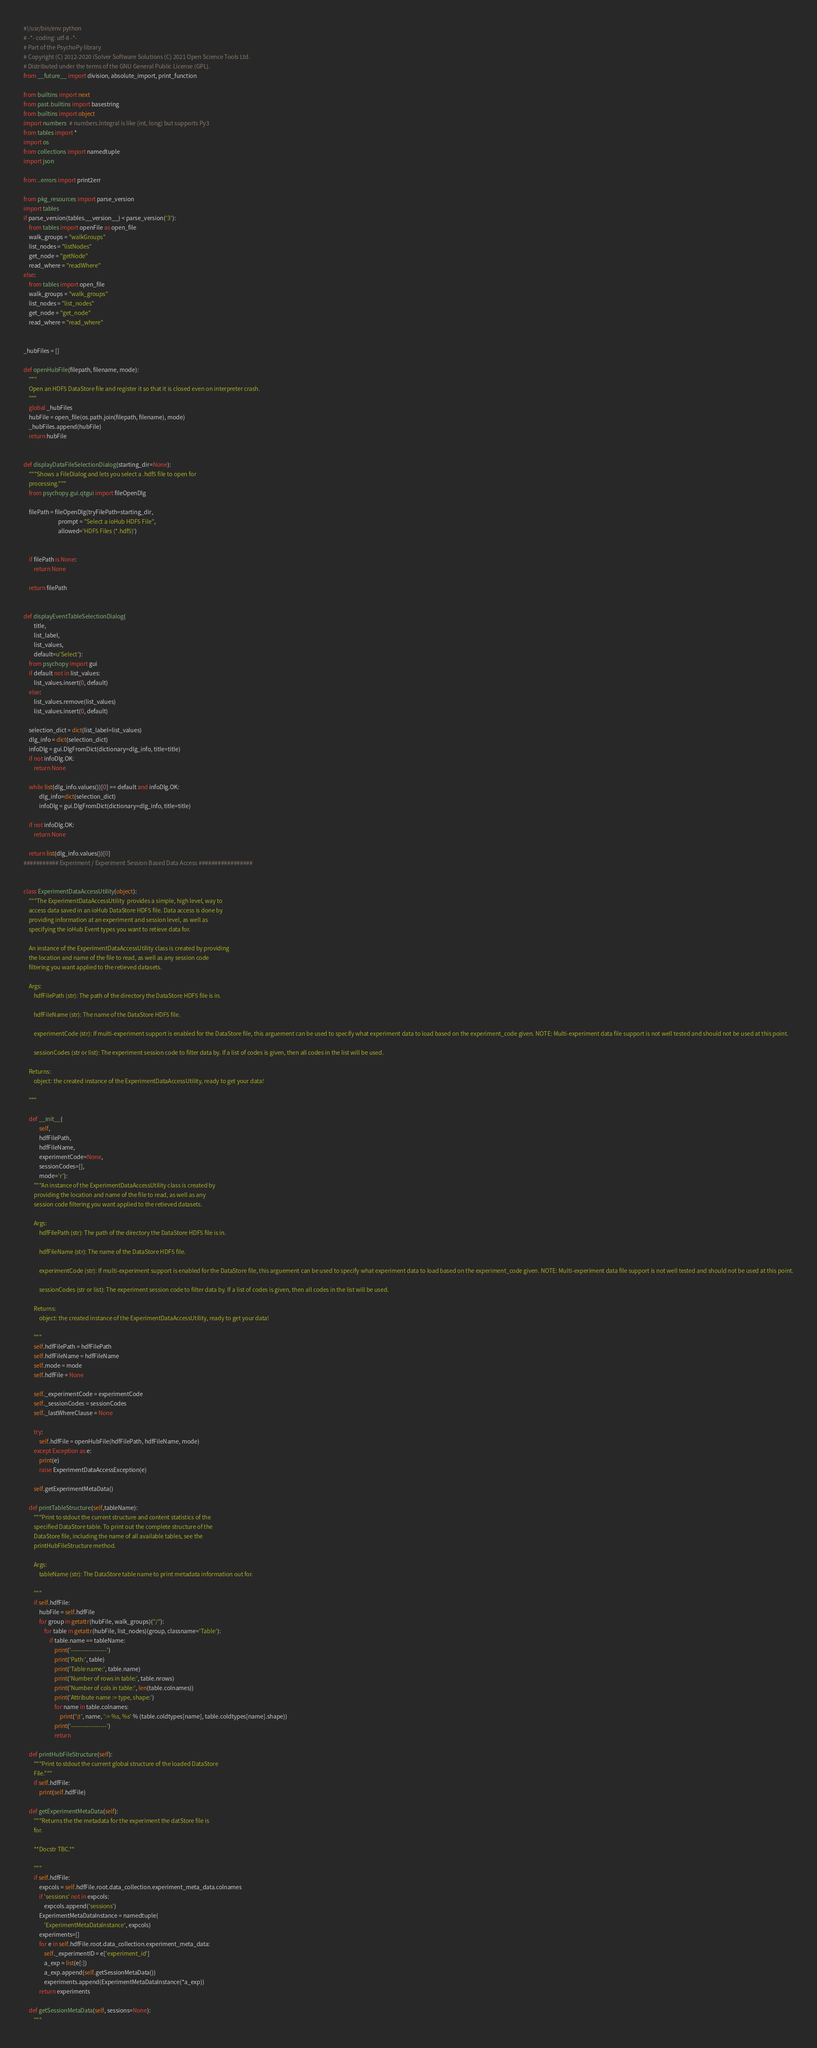Convert code to text. <code><loc_0><loc_0><loc_500><loc_500><_Python_>#!/usr/bin/env python
# -*- coding: utf-8 -*-
# Part of the PsychoPy library
# Copyright (C) 2012-2020 iSolver Software Solutions (C) 2021 Open Science Tools Ltd.
# Distributed under the terms of the GNU General Public License (GPL).
from __future__ import division, absolute_import, print_function

from builtins import next
from past.builtins import basestring
from builtins import object
import numbers  # numbers.Integral is like (int, long) but supports Py3
from tables import *
import os
from collections import namedtuple
import json

from ..errors import print2err

from pkg_resources import parse_version
import tables
if parse_version(tables.__version__) < parse_version('3'):
    from tables import openFile as open_file
    walk_groups = "walkGroups"
    list_nodes = "listNodes"
    get_node = "getNode"
    read_where = "readWhere"
else:
    from tables import open_file
    walk_groups = "walk_groups"
    list_nodes = "list_nodes"
    get_node = "get_node"
    read_where = "read_where"


_hubFiles = []

def openHubFile(filepath, filename, mode):
    """
    Open an HDF5 DataStore file and register it so that it is closed even on interpreter crash.
    """
    global _hubFiles
    hubFile = open_file(os.path.join(filepath, filename), mode)
    _hubFiles.append(hubFile)
    return hubFile


def displayDataFileSelectionDialog(starting_dir=None):
    """Shows a FileDialog and lets you select a .hdf5 file to open for
    processing."""
    from psychopy.gui.qtgui import fileOpenDlg

    filePath = fileOpenDlg(tryFilePath=starting_dir, 
                           prompt = "Select a ioHub HDF5 File",
                           allowed='HDF5 Files (*.hdf5)')
    

    if filePath is None:
        return None

    return filePath


def displayEventTableSelectionDialog(
        title,
        list_label,
        list_values,
        default=u'Select'):
    from psychopy import gui
    if default not in list_values:
        list_values.insert(0, default)
    else:
        list_values.remove(list_values)
        list_values.insert(0, default)

    selection_dict = dict(list_label=list_values)
    dlg_info = dict(selection_dict)
    infoDlg = gui.DlgFromDict(dictionary=dlg_info, title=title)
    if not infoDlg.OK:
        return None

    while list(dlg_info.values())[0] == default and infoDlg.OK:
            dlg_info=dict(selection_dict)
            infoDlg = gui.DlgFromDict(dictionary=dlg_info, title=title)

    if not infoDlg.OK:
        return None

    return list(dlg_info.values())[0]
########### Experiment / Experiment Session Based Data Access #################


class ExperimentDataAccessUtility(object):
    """The ExperimentDataAccessUtility  provides a simple, high level, way to
    access data saved in an ioHub DataStore HDF5 file. Data access is done by
    providing information at an experiment and session level, as well as
    specifying the ioHub Event types you want to retieve data for.

    An instance of the ExperimentDataAccessUtility class is created by providing
    the location and name of the file to read, as well as any session code
    filtering you want applied to the retieved datasets.

    Args:
        hdfFilePath (str): The path of the directory the DataStore HDF5 file is in.

        hdfFileName (str): The name of the DataStore HDF5 file.

        experimentCode (str): If multi-experiment support is enabled for the DataStore file, this arguement can be used to specify what experiment data to load based on the experiment_code given. NOTE: Multi-experiment data file support is not well tested and should not be used at this point.

        sessionCodes (str or list): The experiment session code to filter data by. If a list of codes is given, then all codes in the list will be used.

    Returns:
        object: the created instance of the ExperimentDataAccessUtility, ready to get your data!

    """

    def __init__(
            self,
            hdfFilePath,
            hdfFileName,
            experimentCode=None,
            sessionCodes=[],
            mode='r'):
        """An instance of the ExperimentDataAccessUtility class is created by
        providing the location and name of the file to read, as well as any
        session code filtering you want applied to the retieved datasets.

        Args:
            hdfFilePath (str): The path of the directory the DataStore HDF5 file is in.

            hdfFileName (str): The name of the DataStore HDF5 file.

            experimentCode (str): If multi-experiment support is enabled for the DataStore file, this arguement can be used to specify what experiment data to load based on the experiment_code given. NOTE: Multi-experiment data file support is not well tested and should not be used at this point.

            sessionCodes (str or list): The experiment session code to filter data by. If a list of codes is given, then all codes in the list will be used.

        Returns:
            object: the created instance of the ExperimentDataAccessUtility, ready to get your data!

        """
        self.hdfFilePath = hdfFilePath
        self.hdfFileName = hdfFileName
        self.mode = mode
        self.hdfFile = None

        self._experimentCode = experimentCode
        self._sessionCodes = sessionCodes
        self._lastWhereClause = None

        try:
            self.hdfFile = openHubFile(hdfFilePath, hdfFileName, mode)
        except Exception as e:
            print(e)
            raise ExperimentDataAccessException(e)

        self.getExperimentMetaData()

    def printTableStructure(self,tableName):
        """Print to stdout the current structure and content statistics of the
        specified DataStore table. To print out the complete structure of the
        DataStore file, including the name of all available tables, see the
        printHubFileStructure method.

        Args:
            tableName (str): The DataStore table name to print metadata information out for.

        """
        if self.hdfFile:
            hubFile = self.hdfFile
            for group in getattr(hubFile, walk_groups)("/"):
                for table in getattr(hubFile, list_nodes)(group, classname='Table'):
                    if table.name == tableName:
                        print('------------------')
                        print('Path:', table)
                        print('Table name:', table.name)
                        print('Number of rows in table:', table.nrows)
                        print('Number of cols in table:', len(table.colnames))
                        print('Attribute name := type, shape:')
                        for name in table.colnames:
                            print('\t', name, ':= %s, %s' % (table.coldtypes[name], table.coldtypes[name].shape))
                        print('------------------')
                        return

    def printHubFileStructure(self):
        """Print to stdout the current global structure of the loaded DataStore
        File."""
        if self.hdfFile:
            print(self.hdfFile)

    def getExperimentMetaData(self):
        """Returns the the metadata for the experiment the datStore file is
        for.

        **Docstr TBC.**

        """
        if self.hdfFile:
            expcols = self.hdfFile.root.data_collection.experiment_meta_data.colnames
            if 'sessions' not in expcols:
                expcols.append('sessions')
            ExperimentMetaDataInstance = namedtuple(
                'ExperimentMetaDataInstance', expcols)
            experiments=[]
            for e in self.hdfFile.root.data_collection.experiment_meta_data:
                self._experimentID = e['experiment_id']
                a_exp = list(e[:])
                a_exp.append(self.getSessionMetaData())
                experiments.append(ExperimentMetaDataInstance(*a_exp))
            return experiments

    def getSessionMetaData(self, sessions=None):
        """</code> 